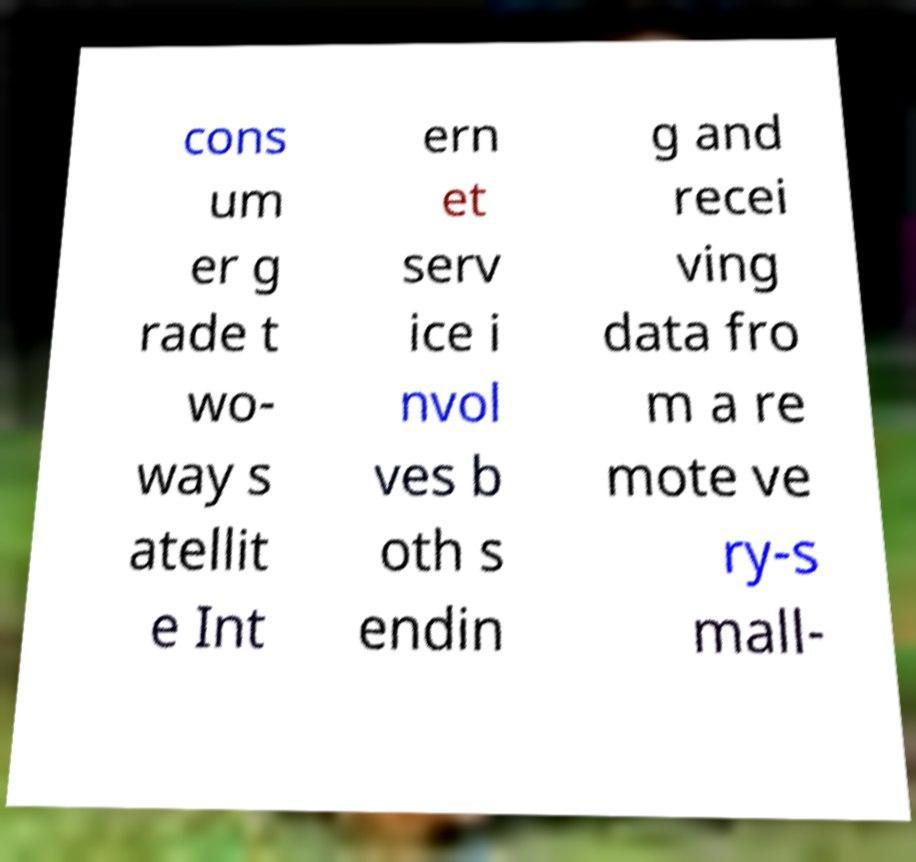Can you read and provide the text displayed in the image?This photo seems to have some interesting text. Can you extract and type it out for me? cons um er g rade t wo- way s atellit e Int ern et serv ice i nvol ves b oth s endin g and recei ving data fro m a re mote ve ry-s mall- 